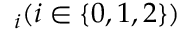Convert formula to latex. <formula><loc_0><loc_0><loc_500><loc_500>\digamma _ { i } ( i \in \{ 0 , 1 , 2 \} )</formula> 